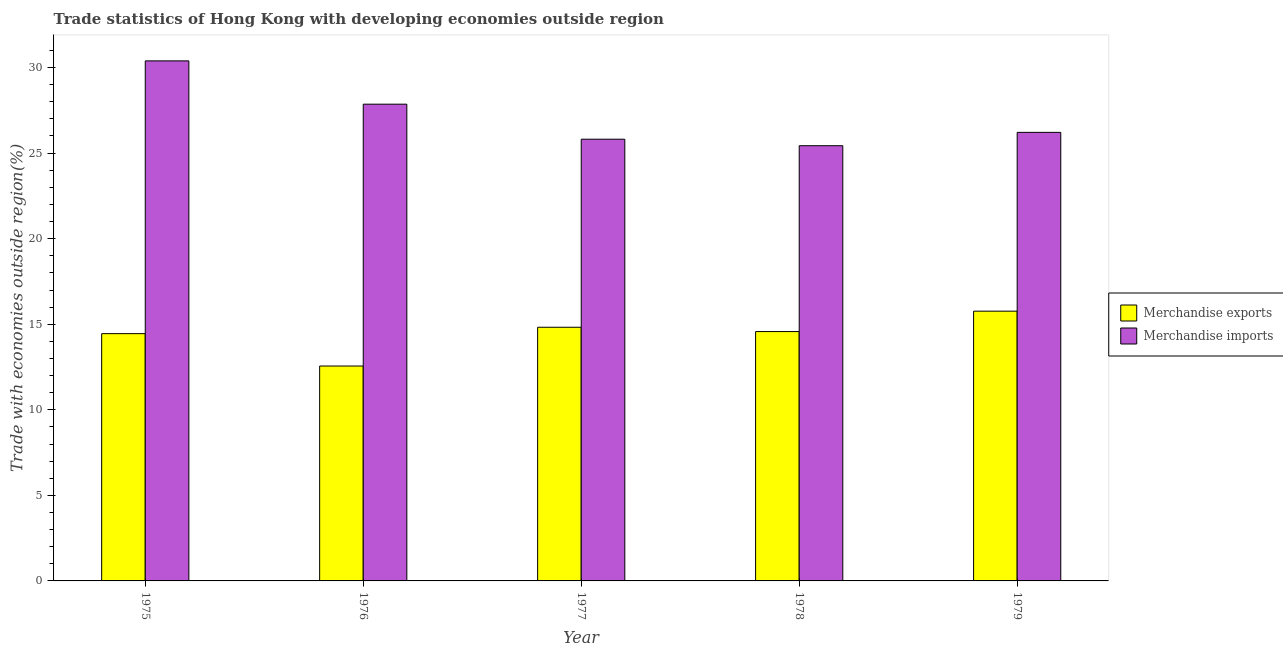Are the number of bars per tick equal to the number of legend labels?
Give a very brief answer. Yes. What is the label of the 1st group of bars from the left?
Keep it short and to the point. 1975. In how many cases, is the number of bars for a given year not equal to the number of legend labels?
Provide a short and direct response. 0. What is the merchandise imports in 1976?
Offer a very short reply. 27.86. Across all years, what is the maximum merchandise exports?
Make the answer very short. 15.76. Across all years, what is the minimum merchandise imports?
Your response must be concise. 25.43. In which year was the merchandise imports maximum?
Provide a short and direct response. 1975. In which year was the merchandise imports minimum?
Offer a very short reply. 1978. What is the total merchandise exports in the graph?
Provide a succinct answer. 72.17. What is the difference between the merchandise imports in 1975 and that in 1978?
Offer a very short reply. 4.96. What is the difference between the merchandise exports in 1977 and the merchandise imports in 1976?
Offer a terse response. 2.27. What is the average merchandise imports per year?
Keep it short and to the point. 27.14. In how many years, is the merchandise exports greater than 7 %?
Provide a short and direct response. 5. What is the ratio of the merchandise exports in 1975 to that in 1976?
Offer a terse response. 1.15. What is the difference between the highest and the second highest merchandise imports?
Make the answer very short. 2.53. What is the difference between the highest and the lowest merchandise imports?
Your response must be concise. 4.96. In how many years, is the merchandise exports greater than the average merchandise exports taken over all years?
Make the answer very short. 4. Is the sum of the merchandise exports in 1978 and 1979 greater than the maximum merchandise imports across all years?
Provide a short and direct response. Yes. How many years are there in the graph?
Offer a very short reply. 5. What is the difference between two consecutive major ticks on the Y-axis?
Give a very brief answer. 5. Where does the legend appear in the graph?
Your answer should be very brief. Center right. How are the legend labels stacked?
Ensure brevity in your answer.  Vertical. What is the title of the graph?
Your response must be concise. Trade statistics of Hong Kong with developing economies outside region. What is the label or title of the Y-axis?
Keep it short and to the point. Trade with economies outside region(%). What is the Trade with economies outside region(%) of Merchandise exports in 1975?
Offer a terse response. 14.45. What is the Trade with economies outside region(%) of Merchandise imports in 1975?
Give a very brief answer. 30.39. What is the Trade with economies outside region(%) of Merchandise exports in 1976?
Provide a succinct answer. 12.56. What is the Trade with economies outside region(%) in Merchandise imports in 1976?
Provide a succinct answer. 27.86. What is the Trade with economies outside region(%) in Merchandise exports in 1977?
Provide a succinct answer. 14.82. What is the Trade with economies outside region(%) of Merchandise imports in 1977?
Your response must be concise. 25.81. What is the Trade with economies outside region(%) in Merchandise exports in 1978?
Offer a very short reply. 14.57. What is the Trade with economies outside region(%) of Merchandise imports in 1978?
Ensure brevity in your answer.  25.43. What is the Trade with economies outside region(%) of Merchandise exports in 1979?
Your answer should be very brief. 15.76. What is the Trade with economies outside region(%) of Merchandise imports in 1979?
Keep it short and to the point. 26.21. Across all years, what is the maximum Trade with economies outside region(%) in Merchandise exports?
Keep it short and to the point. 15.76. Across all years, what is the maximum Trade with economies outside region(%) in Merchandise imports?
Provide a short and direct response. 30.39. Across all years, what is the minimum Trade with economies outside region(%) of Merchandise exports?
Keep it short and to the point. 12.56. Across all years, what is the minimum Trade with economies outside region(%) of Merchandise imports?
Make the answer very short. 25.43. What is the total Trade with economies outside region(%) of Merchandise exports in the graph?
Your answer should be very brief. 72.17. What is the total Trade with economies outside region(%) of Merchandise imports in the graph?
Make the answer very short. 135.71. What is the difference between the Trade with economies outside region(%) in Merchandise exports in 1975 and that in 1976?
Keep it short and to the point. 1.89. What is the difference between the Trade with economies outside region(%) of Merchandise imports in 1975 and that in 1976?
Ensure brevity in your answer.  2.53. What is the difference between the Trade with economies outside region(%) in Merchandise exports in 1975 and that in 1977?
Your answer should be compact. -0.37. What is the difference between the Trade with economies outside region(%) of Merchandise imports in 1975 and that in 1977?
Give a very brief answer. 4.58. What is the difference between the Trade with economies outside region(%) in Merchandise exports in 1975 and that in 1978?
Keep it short and to the point. -0.12. What is the difference between the Trade with economies outside region(%) in Merchandise imports in 1975 and that in 1978?
Your response must be concise. 4.96. What is the difference between the Trade with economies outside region(%) of Merchandise exports in 1975 and that in 1979?
Your answer should be very brief. -1.31. What is the difference between the Trade with economies outside region(%) of Merchandise imports in 1975 and that in 1979?
Your answer should be compact. 4.18. What is the difference between the Trade with economies outside region(%) of Merchandise exports in 1976 and that in 1977?
Give a very brief answer. -2.27. What is the difference between the Trade with economies outside region(%) of Merchandise imports in 1976 and that in 1977?
Offer a terse response. 2.05. What is the difference between the Trade with economies outside region(%) of Merchandise exports in 1976 and that in 1978?
Give a very brief answer. -2.01. What is the difference between the Trade with economies outside region(%) of Merchandise imports in 1976 and that in 1978?
Keep it short and to the point. 2.43. What is the difference between the Trade with economies outside region(%) in Merchandise exports in 1976 and that in 1979?
Offer a terse response. -3.21. What is the difference between the Trade with economies outside region(%) of Merchandise imports in 1976 and that in 1979?
Make the answer very short. 1.65. What is the difference between the Trade with economies outside region(%) in Merchandise exports in 1977 and that in 1978?
Provide a succinct answer. 0.25. What is the difference between the Trade with economies outside region(%) in Merchandise imports in 1977 and that in 1978?
Provide a short and direct response. 0.38. What is the difference between the Trade with economies outside region(%) of Merchandise exports in 1977 and that in 1979?
Provide a short and direct response. -0.94. What is the difference between the Trade with economies outside region(%) of Merchandise imports in 1977 and that in 1979?
Your answer should be compact. -0.4. What is the difference between the Trade with economies outside region(%) in Merchandise exports in 1978 and that in 1979?
Your answer should be very brief. -1.19. What is the difference between the Trade with economies outside region(%) of Merchandise imports in 1978 and that in 1979?
Offer a terse response. -0.78. What is the difference between the Trade with economies outside region(%) of Merchandise exports in 1975 and the Trade with economies outside region(%) of Merchandise imports in 1976?
Offer a terse response. -13.41. What is the difference between the Trade with economies outside region(%) of Merchandise exports in 1975 and the Trade with economies outside region(%) of Merchandise imports in 1977?
Your answer should be very brief. -11.36. What is the difference between the Trade with economies outside region(%) in Merchandise exports in 1975 and the Trade with economies outside region(%) in Merchandise imports in 1978?
Offer a terse response. -10.98. What is the difference between the Trade with economies outside region(%) of Merchandise exports in 1975 and the Trade with economies outside region(%) of Merchandise imports in 1979?
Your answer should be compact. -11.76. What is the difference between the Trade with economies outside region(%) of Merchandise exports in 1976 and the Trade with economies outside region(%) of Merchandise imports in 1977?
Offer a very short reply. -13.26. What is the difference between the Trade with economies outside region(%) in Merchandise exports in 1976 and the Trade with economies outside region(%) in Merchandise imports in 1978?
Provide a short and direct response. -12.87. What is the difference between the Trade with economies outside region(%) of Merchandise exports in 1976 and the Trade with economies outside region(%) of Merchandise imports in 1979?
Offer a terse response. -13.65. What is the difference between the Trade with economies outside region(%) of Merchandise exports in 1977 and the Trade with economies outside region(%) of Merchandise imports in 1978?
Provide a short and direct response. -10.61. What is the difference between the Trade with economies outside region(%) of Merchandise exports in 1977 and the Trade with economies outside region(%) of Merchandise imports in 1979?
Your answer should be very brief. -11.39. What is the difference between the Trade with economies outside region(%) of Merchandise exports in 1978 and the Trade with economies outside region(%) of Merchandise imports in 1979?
Provide a short and direct response. -11.64. What is the average Trade with economies outside region(%) in Merchandise exports per year?
Offer a terse response. 14.43. What is the average Trade with economies outside region(%) in Merchandise imports per year?
Give a very brief answer. 27.14. In the year 1975, what is the difference between the Trade with economies outside region(%) in Merchandise exports and Trade with economies outside region(%) in Merchandise imports?
Ensure brevity in your answer.  -15.94. In the year 1976, what is the difference between the Trade with economies outside region(%) in Merchandise exports and Trade with economies outside region(%) in Merchandise imports?
Keep it short and to the point. -15.3. In the year 1977, what is the difference between the Trade with economies outside region(%) of Merchandise exports and Trade with economies outside region(%) of Merchandise imports?
Your response must be concise. -10.99. In the year 1978, what is the difference between the Trade with economies outside region(%) of Merchandise exports and Trade with economies outside region(%) of Merchandise imports?
Keep it short and to the point. -10.86. In the year 1979, what is the difference between the Trade with economies outside region(%) in Merchandise exports and Trade with economies outside region(%) in Merchandise imports?
Offer a very short reply. -10.45. What is the ratio of the Trade with economies outside region(%) of Merchandise exports in 1975 to that in 1976?
Your answer should be very brief. 1.15. What is the ratio of the Trade with economies outside region(%) of Merchandise imports in 1975 to that in 1976?
Provide a short and direct response. 1.09. What is the ratio of the Trade with economies outside region(%) in Merchandise exports in 1975 to that in 1977?
Your answer should be very brief. 0.97. What is the ratio of the Trade with economies outside region(%) in Merchandise imports in 1975 to that in 1977?
Your response must be concise. 1.18. What is the ratio of the Trade with economies outside region(%) of Merchandise imports in 1975 to that in 1978?
Your response must be concise. 1.19. What is the ratio of the Trade with economies outside region(%) of Merchandise exports in 1975 to that in 1979?
Offer a terse response. 0.92. What is the ratio of the Trade with economies outside region(%) in Merchandise imports in 1975 to that in 1979?
Offer a very short reply. 1.16. What is the ratio of the Trade with economies outside region(%) of Merchandise exports in 1976 to that in 1977?
Your response must be concise. 0.85. What is the ratio of the Trade with economies outside region(%) in Merchandise imports in 1976 to that in 1977?
Keep it short and to the point. 1.08. What is the ratio of the Trade with economies outside region(%) in Merchandise exports in 1976 to that in 1978?
Make the answer very short. 0.86. What is the ratio of the Trade with economies outside region(%) in Merchandise imports in 1976 to that in 1978?
Provide a succinct answer. 1.1. What is the ratio of the Trade with economies outside region(%) in Merchandise exports in 1976 to that in 1979?
Provide a short and direct response. 0.8. What is the ratio of the Trade with economies outside region(%) in Merchandise imports in 1976 to that in 1979?
Provide a succinct answer. 1.06. What is the ratio of the Trade with economies outside region(%) of Merchandise exports in 1977 to that in 1978?
Ensure brevity in your answer.  1.02. What is the ratio of the Trade with economies outside region(%) of Merchandise imports in 1977 to that in 1978?
Keep it short and to the point. 1.01. What is the ratio of the Trade with economies outside region(%) of Merchandise exports in 1977 to that in 1979?
Offer a terse response. 0.94. What is the ratio of the Trade with economies outside region(%) in Merchandise imports in 1977 to that in 1979?
Give a very brief answer. 0.98. What is the ratio of the Trade with economies outside region(%) of Merchandise exports in 1978 to that in 1979?
Offer a very short reply. 0.92. What is the ratio of the Trade with economies outside region(%) in Merchandise imports in 1978 to that in 1979?
Provide a short and direct response. 0.97. What is the difference between the highest and the second highest Trade with economies outside region(%) of Merchandise exports?
Ensure brevity in your answer.  0.94. What is the difference between the highest and the second highest Trade with economies outside region(%) of Merchandise imports?
Offer a very short reply. 2.53. What is the difference between the highest and the lowest Trade with economies outside region(%) in Merchandise exports?
Give a very brief answer. 3.21. What is the difference between the highest and the lowest Trade with economies outside region(%) of Merchandise imports?
Provide a short and direct response. 4.96. 